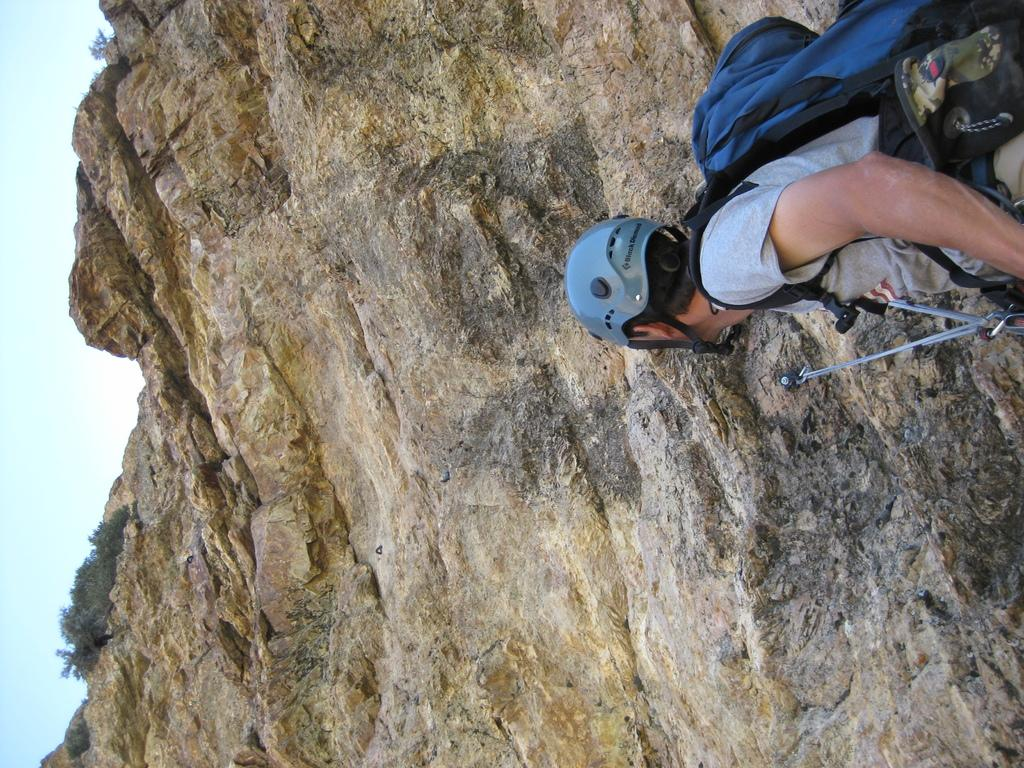Who or what is in the image? There is a person in the image. What is the person standing in front of? The person is standing in front of a hill. What is the person wearing on their back? The person is wearing a bag. What type of protective gear is the person wearing on their head? The person is wearing a helmet. What direction is the person looking in? The person is looking upwards. What type of worm can be seen crawling on the person's tongue in the image? There is no worm present in the image, nor is there any mention of a tongue. 